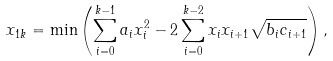Convert formula to latex. <formula><loc_0><loc_0><loc_500><loc_500>x _ { 1 k } = \min \left ( \sum _ { i = 0 } ^ { k - 1 } a _ { i } x _ { i } ^ { 2 } - 2 \sum _ { i = 0 } ^ { k - 2 } x _ { i } x _ { i + 1 } \sqrt { b _ { i } c _ { i + 1 } } \right ) ,</formula> 